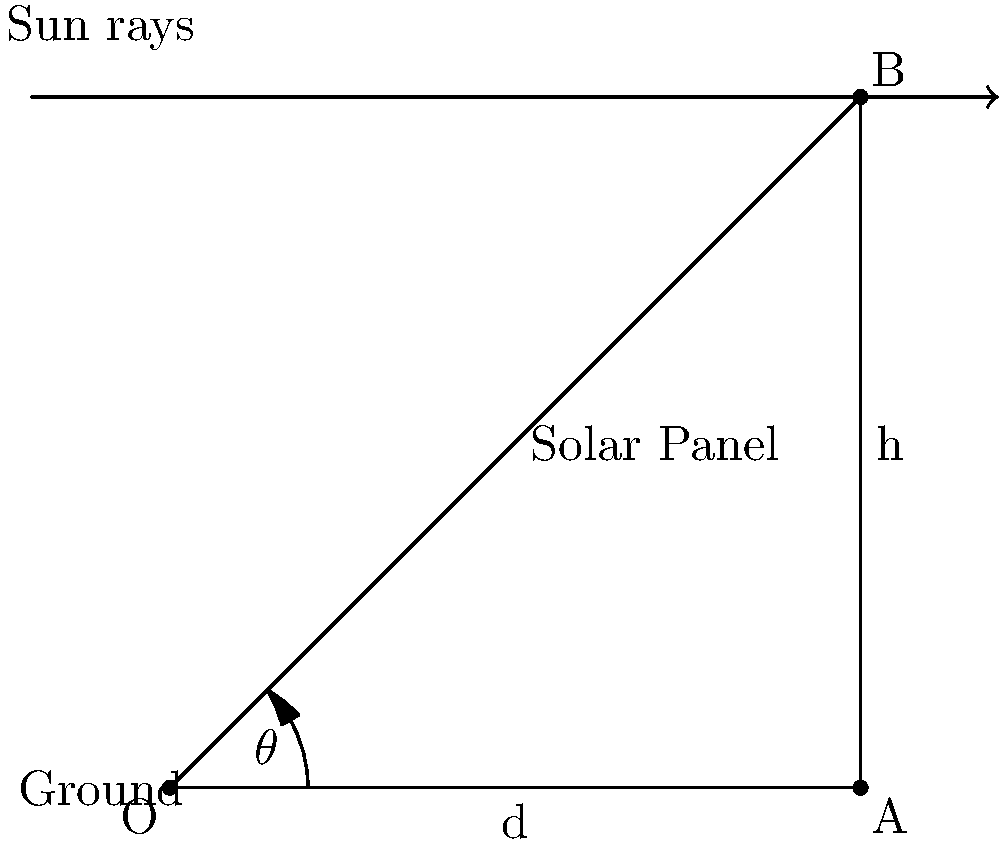As a bond trader in environmental finance, you're evaluating a green building project that includes solar panels. The building is located at a latitude where the sun's altitude angle is 45° at noon. To maximize energy production and project returns, you need to determine the optimal tilt angle for the solar panels. Given that the panel's height (h) is 5 meters when tilted, what should be the tilt angle $\theta$ of the solar panel with respect to the ground to ensure it's perpendicular to the sun's rays at noon? Let's approach this step-by-step:

1) For maximum efficiency, the solar panel should be perpendicular to the sun's rays at noon.

2) The sun's altitude angle is given as 45°. This means that the sun's rays make a 45° angle with the ground.

3) For the panel to be perpendicular to the sun's rays, it must form a right angle (90°) with them.

4) Therefore, the angle between the panel and the ground ($\theta$) plus 45° must equal 90°.

5) We can express this as an equation:
   $$ \theta + 45° = 90° $$

6) Solving for $\theta$:
   $$ \theta = 90° - 45° = 45° $$

7) We can verify this using the right triangle formed by the panel:
   - The hypotenuse is the panel itself (5 meters)
   - One leg is the height (h = 5 meters)
   - For a 45° angle, this forms an isosceles right triangle where both legs are equal

8) We can confirm using the Pythagorean theorem:
   $$ d^2 + h^2 = 5^2 $$
   $$ d^2 + 5^2 = 5^2 $$
   $$ d^2 = 25 - 25 = 0 $$
   $$ d = 0 $$

This confirms that the panel is indeed at a 45° angle to the ground.
Answer: 45° 